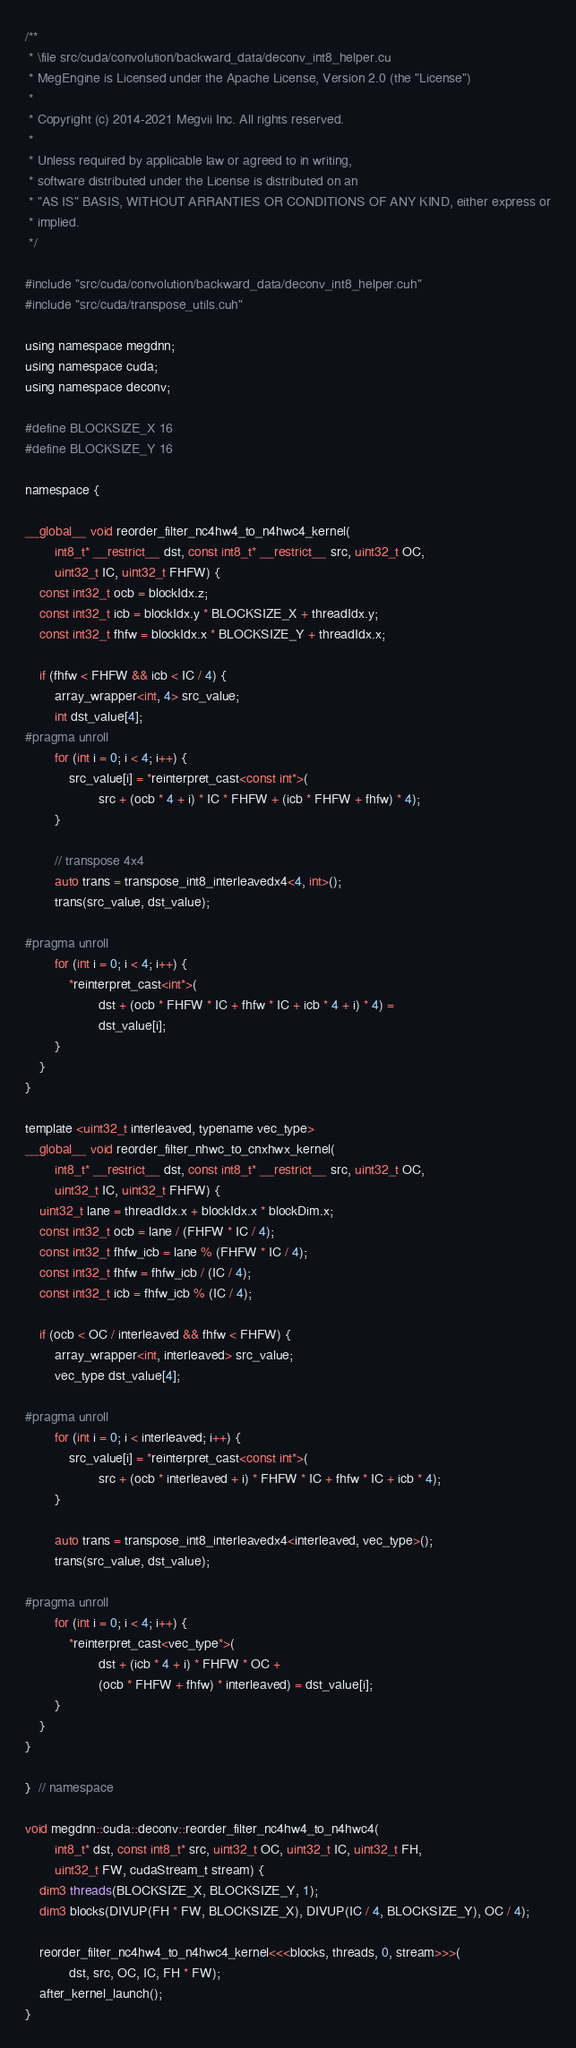<code> <loc_0><loc_0><loc_500><loc_500><_Cuda_>/**
 * \file src/cuda/convolution/backward_data/deconv_int8_helper.cu
 * MegEngine is Licensed under the Apache License, Version 2.0 (the "License")
 *
 * Copyright (c) 2014-2021 Megvii Inc. All rights reserved.
 *
 * Unless required by applicable law or agreed to in writing,
 * software distributed under the License is distributed on an
 * "AS IS" BASIS, WITHOUT ARRANTIES OR CONDITIONS OF ANY KIND, either express or
 * implied.
 */

#include "src/cuda/convolution/backward_data/deconv_int8_helper.cuh"
#include "src/cuda/transpose_utils.cuh"

using namespace megdnn;
using namespace cuda;
using namespace deconv;

#define BLOCKSIZE_X 16
#define BLOCKSIZE_Y 16

namespace {

__global__ void reorder_filter_nc4hw4_to_n4hwc4_kernel(
        int8_t* __restrict__ dst, const int8_t* __restrict__ src, uint32_t OC,
        uint32_t IC, uint32_t FHFW) {
    const int32_t ocb = blockIdx.z;
    const int32_t icb = blockIdx.y * BLOCKSIZE_X + threadIdx.y;
    const int32_t fhfw = blockIdx.x * BLOCKSIZE_Y + threadIdx.x;

    if (fhfw < FHFW && icb < IC / 4) {
        array_wrapper<int, 4> src_value;
        int dst_value[4];
#pragma unroll
        for (int i = 0; i < 4; i++) {
            src_value[i] = *reinterpret_cast<const int*>(
                    src + (ocb * 4 + i) * IC * FHFW + (icb * FHFW + fhfw) * 4);
        }

        // transpose 4x4
        auto trans = transpose_int8_interleavedx4<4, int>();
        trans(src_value, dst_value);

#pragma unroll
        for (int i = 0; i < 4; i++) {
            *reinterpret_cast<int*>(
                    dst + (ocb * FHFW * IC + fhfw * IC + icb * 4 + i) * 4) =
                    dst_value[i];
        }
    }
}

template <uint32_t interleaved, typename vec_type>
__global__ void reorder_filter_nhwc_to_cnxhwx_kernel(
        int8_t* __restrict__ dst, const int8_t* __restrict__ src, uint32_t OC,
        uint32_t IC, uint32_t FHFW) {
    uint32_t lane = threadIdx.x + blockIdx.x * blockDim.x;
    const int32_t ocb = lane / (FHFW * IC / 4);
    const int32_t fhfw_icb = lane % (FHFW * IC / 4);
    const int32_t fhfw = fhfw_icb / (IC / 4);
    const int32_t icb = fhfw_icb % (IC / 4);

    if (ocb < OC / interleaved && fhfw < FHFW) {
        array_wrapper<int, interleaved> src_value;
        vec_type dst_value[4];

#pragma unroll
        for (int i = 0; i < interleaved; i++) {
            src_value[i] = *reinterpret_cast<const int*>(
                    src + (ocb * interleaved + i) * FHFW * IC + fhfw * IC + icb * 4);
        }

        auto trans = transpose_int8_interleavedx4<interleaved, vec_type>();
        trans(src_value, dst_value);

#pragma unroll
        for (int i = 0; i < 4; i++) {
            *reinterpret_cast<vec_type*>(
                    dst + (icb * 4 + i) * FHFW * OC +
                    (ocb * FHFW + fhfw) * interleaved) = dst_value[i];
        }
    }
}

}  // namespace

void megdnn::cuda::deconv::reorder_filter_nc4hw4_to_n4hwc4(
        int8_t* dst, const int8_t* src, uint32_t OC, uint32_t IC, uint32_t FH,
        uint32_t FW, cudaStream_t stream) {
    dim3 threads(BLOCKSIZE_X, BLOCKSIZE_Y, 1);
    dim3 blocks(DIVUP(FH * FW, BLOCKSIZE_X), DIVUP(IC / 4, BLOCKSIZE_Y), OC / 4);

    reorder_filter_nc4hw4_to_n4hwc4_kernel<<<blocks, threads, 0, stream>>>(
            dst, src, OC, IC, FH * FW);
    after_kernel_launch();
}
</code> 